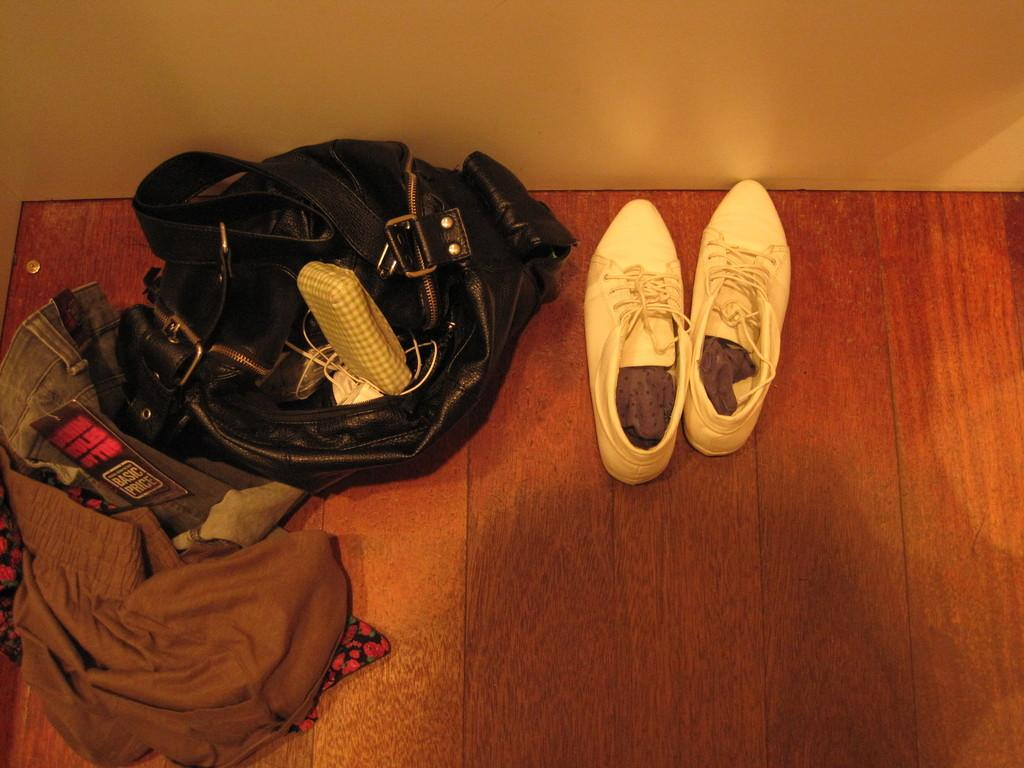What type of surface is visible in the image? There is a wooden surface in the image. What items can be seen on the wooden surface? There are footwear, clothes, and a bag with some objects on the wooden surface. What else is visible in the image besides the wooden surface? There is a wall visible in the image. Can you see any pins holding the clothes on the wooden surface? There is no mention of pins in the image, and the clothes appear to be placed on the wooden surface without any visible means of attachment. Is there any cheese visible on the wooden surface? There is no cheese present in the image. 